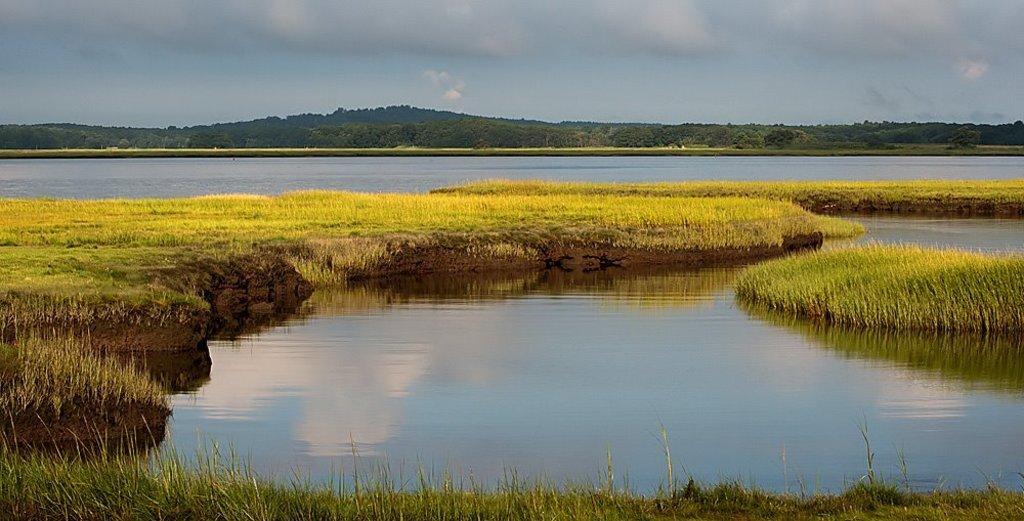Describe this image in one or two sentences. This picture is clicked outside. In the foreground we can see a water body and we can see the grass. In the background we can see the sky, hills, trees and some other objects. 